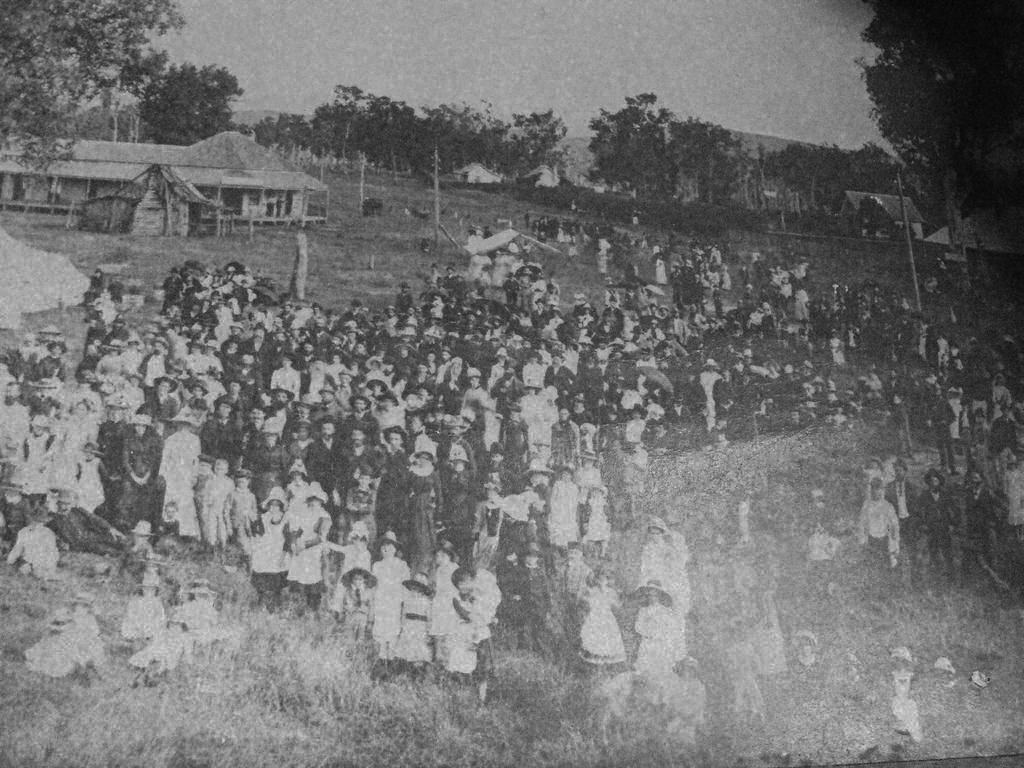What is the color scheme of the image? The image is black and white. What are the people in the image doing? The people are sitting on the grass in the image. What type of structure is visible in the image? There is a building in the image. What other natural elements can be seen in the image? There are trees in the image. How many plates are visible on the grass in the image? There are no plates visible in the image; people are sitting on the grass. Can you describe the skateboarding activity taking place in the image? There is no skateboarding activity present in the image. 